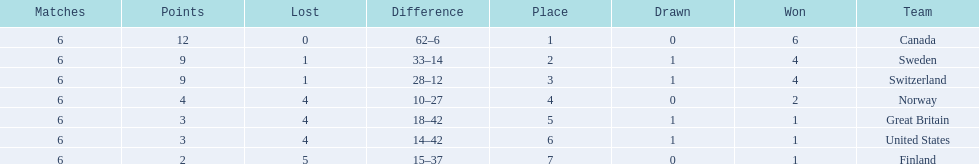What team placed next after sweden? Switzerland. 